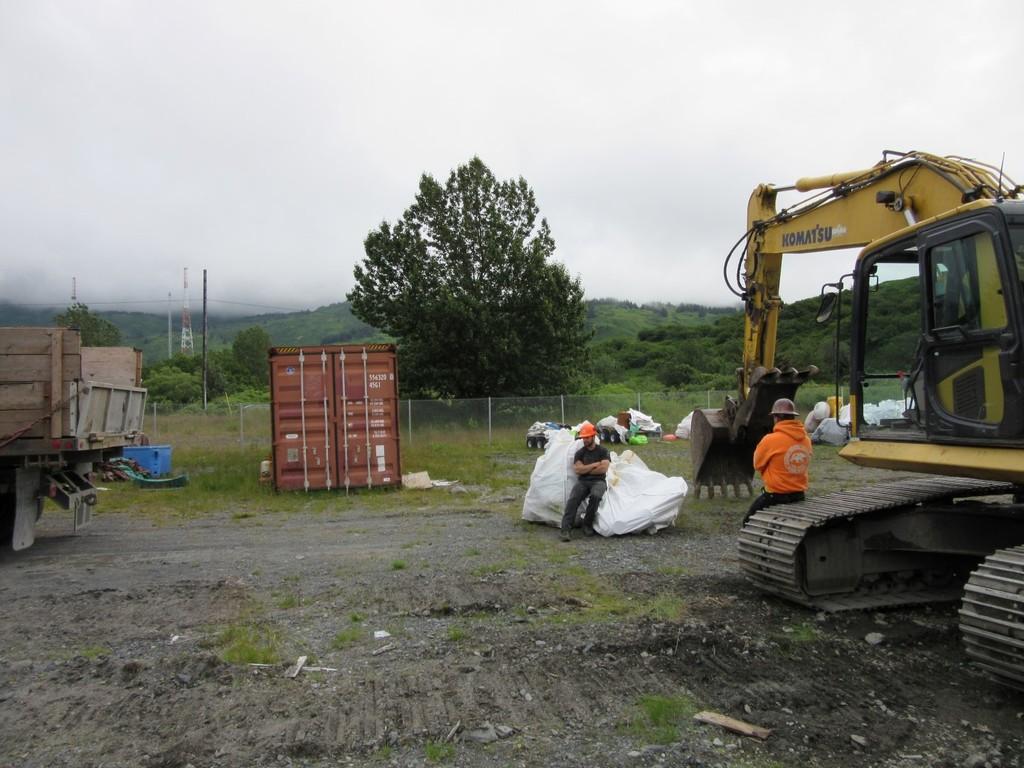What brand machine is this?
Make the answer very short. Komatsu. What type of machine is that?
Give a very brief answer. Komatsu. 